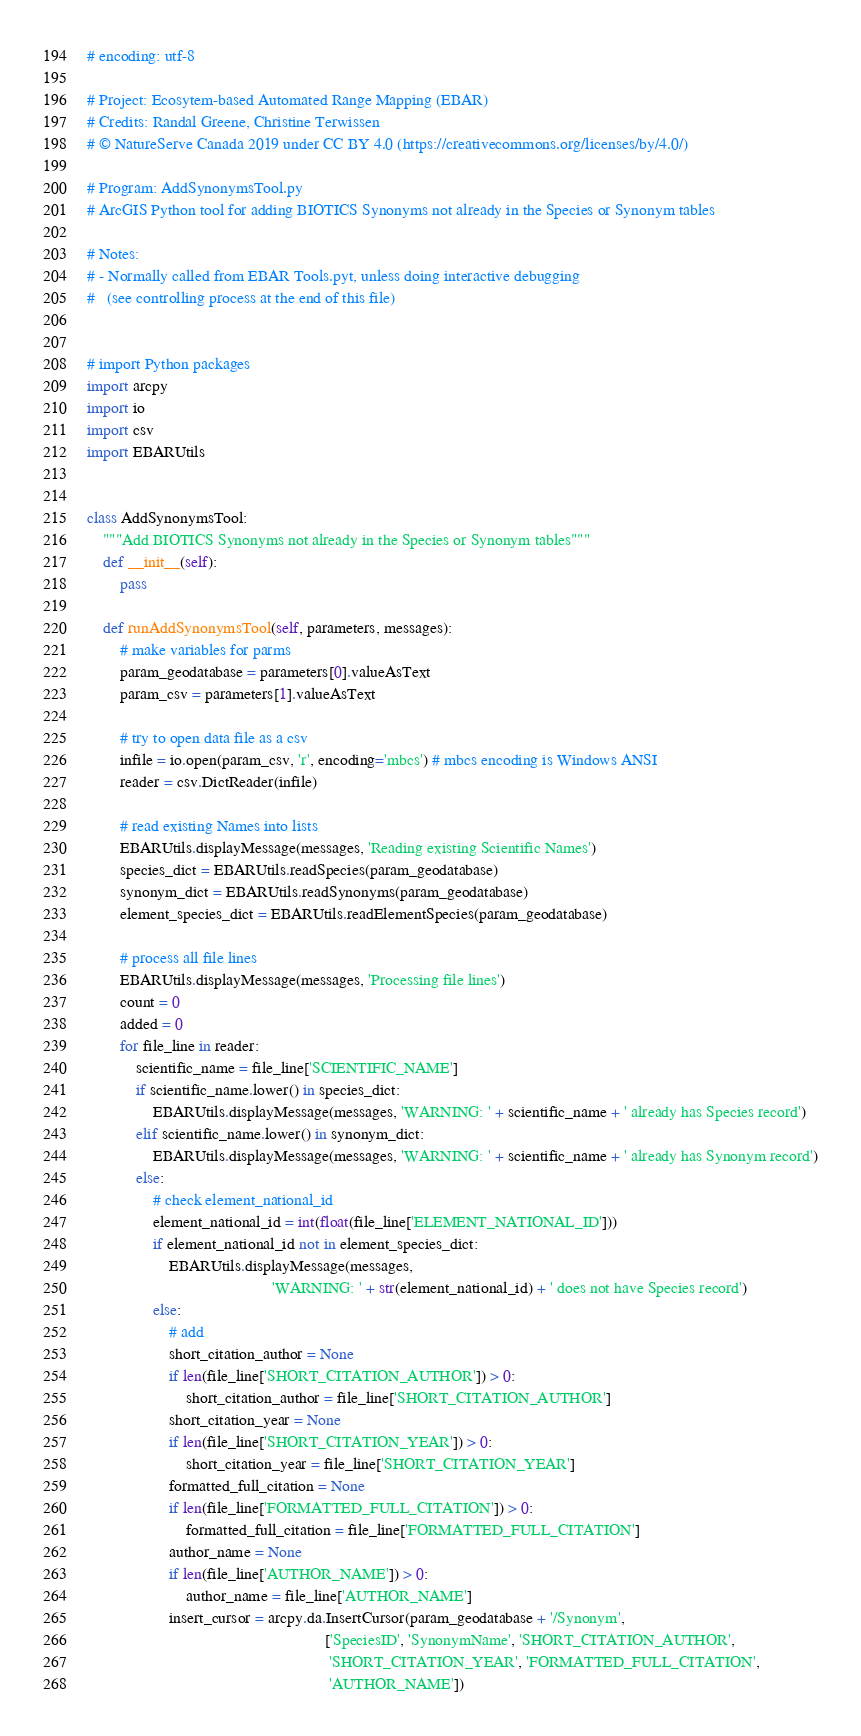<code> <loc_0><loc_0><loc_500><loc_500><_Python_># encoding: utf-8

# Project: Ecosytem-based Automated Range Mapping (EBAR)
# Credits: Randal Greene, Christine Terwissen
# © NatureServe Canada 2019 under CC BY 4.0 (https://creativecommons.org/licenses/by/4.0/)

# Program: AddSynonymsTool.py
# ArcGIS Python tool for adding BIOTICS Synonyms not already in the Species or Synonym tables

# Notes:
# - Normally called from EBAR Tools.pyt, unless doing interactive debugging
#   (see controlling process at the end of this file)


# import Python packages
import arcpy
import io
import csv
import EBARUtils


class AddSynonymsTool:
    """Add BIOTICS Synonyms not already in the Species or Synonym tables"""
    def __init__(self):
        pass

    def runAddSynonymsTool(self, parameters, messages):
        # make variables for parms
        param_geodatabase = parameters[0].valueAsText
        param_csv = parameters[1].valueAsText

        # try to open data file as a csv
        infile = io.open(param_csv, 'r', encoding='mbcs') # mbcs encoding is Windows ANSI
        reader = csv.DictReader(infile)

        # read existing Names into lists
        EBARUtils.displayMessage(messages, 'Reading existing Scientific Names')
        species_dict = EBARUtils.readSpecies(param_geodatabase)
        synonym_dict = EBARUtils.readSynonyms(param_geodatabase)
        element_species_dict = EBARUtils.readElementSpecies(param_geodatabase)

        # process all file lines
        EBARUtils.displayMessage(messages, 'Processing file lines')
        count = 0
        added = 0
        for file_line in reader:
            scientific_name = file_line['SCIENTIFIC_NAME']
            if scientific_name.lower() in species_dict:
                EBARUtils.displayMessage(messages, 'WARNING: ' + scientific_name + ' already has Species record')
            elif scientific_name.lower() in synonym_dict:
                EBARUtils.displayMessage(messages, 'WARNING: ' + scientific_name + ' already has Synonym record')
            else:
                # check element_national_id
                element_national_id = int(float(file_line['ELEMENT_NATIONAL_ID']))
                if element_national_id not in element_species_dict:
                    EBARUtils.displayMessage(messages,
                                             'WARNING: ' + str(element_national_id) + ' does not have Species record')
                else:
                    # add
                    short_citation_author = None
                    if len(file_line['SHORT_CITATION_AUTHOR']) > 0:
                        short_citation_author = file_line['SHORT_CITATION_AUTHOR']
                    short_citation_year = None
                    if len(file_line['SHORT_CITATION_YEAR']) > 0:
                        short_citation_year = file_line['SHORT_CITATION_YEAR']
                    formatted_full_citation = None
                    if len(file_line['FORMATTED_FULL_CITATION']) > 0:
                        formatted_full_citation = file_line['FORMATTED_FULL_CITATION']
                    author_name = None
                    if len(file_line['AUTHOR_NAME']) > 0:
                        author_name = file_line['AUTHOR_NAME']
                    insert_cursor = arcpy.da.InsertCursor(param_geodatabase + '/Synonym',
                                                          ['SpeciesID', 'SynonymName', 'SHORT_CITATION_AUTHOR',
                                                           'SHORT_CITATION_YEAR', 'FORMATTED_FULL_CITATION',
                                                           'AUTHOR_NAME'])</code> 